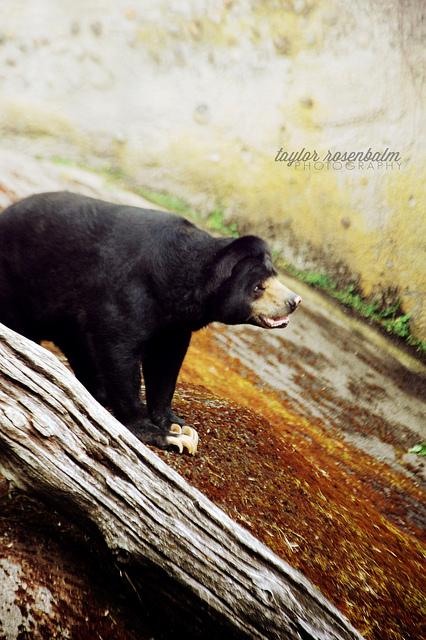Did a professional take the picture?
Give a very brief answer. Yes. Is the bear about to attack?
Keep it brief. No. What sort of animal is in the picture?
Short answer required. Bear. 